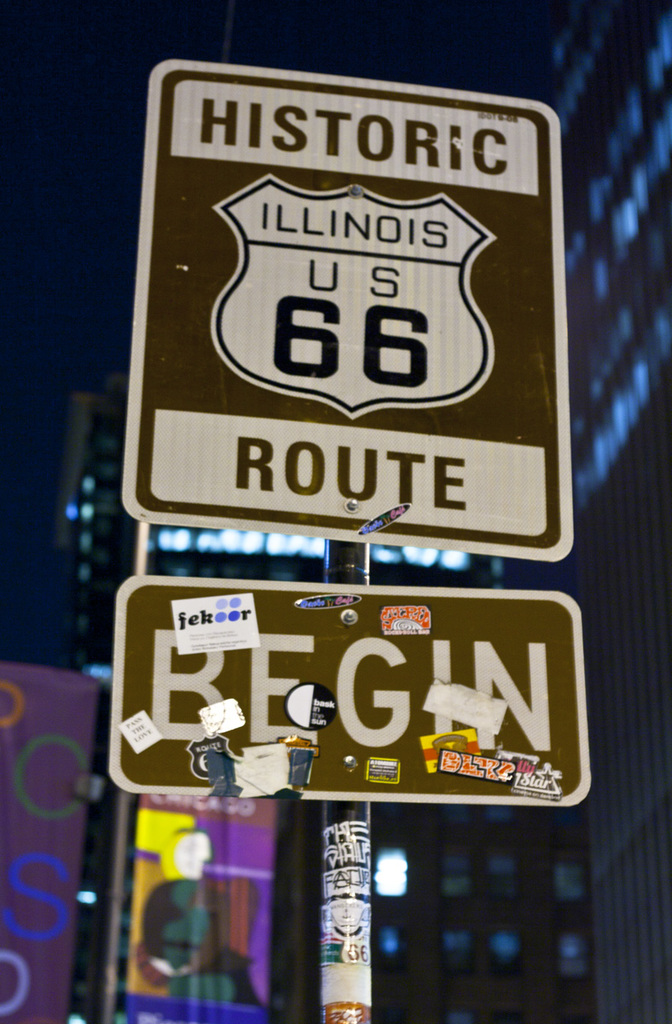How has Route 66 contributed to American culture? Route 66 has played a pivotal role in American culture, often referred to as the 'Mother Road'. It has been a symbol of opportunity and hope, connecting the Midwest to the West Coast. The route has inspired countless works of art, music, and literature, capturing the American spirit of freedom and exploration. Its influence is evident in popular culture, embodying the backdrop for many stories of escape, adventure, and self-discovery, making it more than just a road—it's a cultural landmark. Can you tell me about any famous literature or songs inspired by Route 66? Certainly! Route 66 has inspired numerous pieces of iconic American literature and music. One of the most famous songs is '(Get Your Kicks on) Route 66', popularized by Nat King Cole, which celebrates the journey along this historic highway. In literature, John Steinbeck's novel 'The Grapes of Wrath' famously depicts Route 66 as the 'Mother Road', providing a path for displaced families during the Dust Bowl migration. These works highlight Route 66's emblematic role in narratives of American mobility and adventure. 